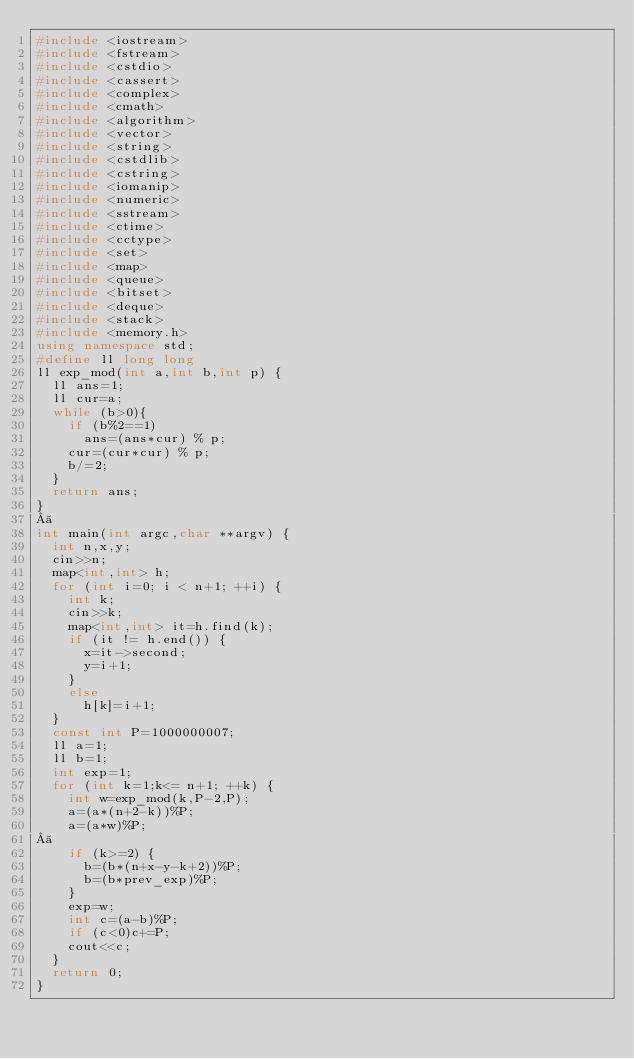<code> <loc_0><loc_0><loc_500><loc_500><_C++_>#include <iostream>
#include <fstream>
#include <cstdio>
#include <cassert>
#include <complex>
#include <cmath>
#include <algorithm>
#include <vector>
#include <string>
#include <cstdlib>
#include <cstring>
#include <iomanip>
#include <numeric>
#include <sstream>
#include <ctime>
#include <cctype>
#include <set>
#include <map>
#include <queue>
#include <bitset>
#include <deque>
#include <stack>
#include <memory.h>
using namespace std;
#define ll long long 
ll exp_mod(int a,int b,int p) {
  ll ans=1;
  ll cur=a;
  while (b>0){
    if (b%2==1)
      ans=(ans*cur) % p;
    cur=(cur*cur) % p;
    b/=2;
  }
  return ans;
}
 
int main(int argc,char **argv) {
  int n,x,y;
  cin>>n;
  map<int,int> h;
  for (int i=0; i < n+1; ++i) {
    int k;
    cin>>k;
    map<int,int> it=h.find(k);
    if (it != h.end()) {
      x=it->second;
      y=i+1;
    }
    else
      h[k]=i+1;
  }
  const int P=1000000007;
  ll a=1;
  ll b=1;
  int exp=1;
  for (int k=1;k<= n+1; ++k) {
    int w=exp_mod(k,P-2,P);
    a=(a*(n+2-k))%P;
    a=(a*w)%P;
 
    if (k>=2) {
      b=(b*(n+x-y-k+2))%P;
      b=(b*prev_exp)%P;
    }
    exp=w;
    int c=(a-b)%P;
    if (c<0)c+=P;
    cout<<c;
  }
  return 0;
}</code> 